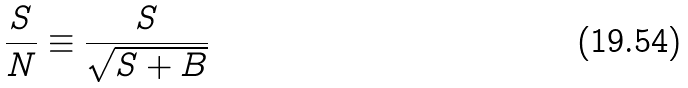Convert formula to latex. <formula><loc_0><loc_0><loc_500><loc_500>\frac { S } { N } \equiv \frac { S } { \sqrt { S + B } }</formula> 